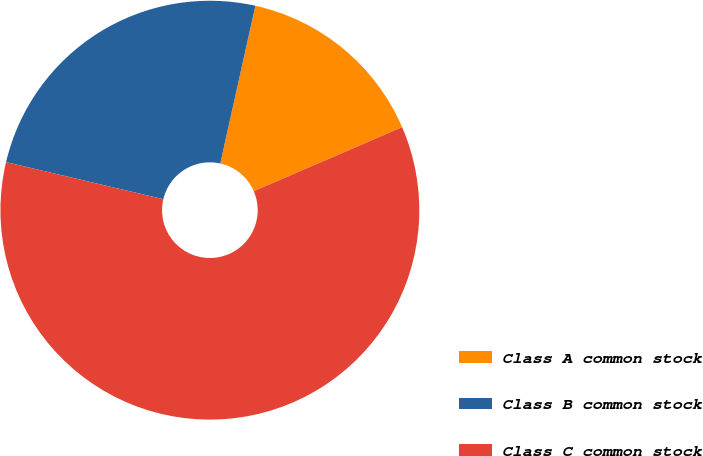Convert chart. <chart><loc_0><loc_0><loc_500><loc_500><pie_chart><fcel>Class A common stock<fcel>Class B common stock<fcel>Class C common stock<nl><fcel>15.03%<fcel>24.8%<fcel>60.17%<nl></chart> 